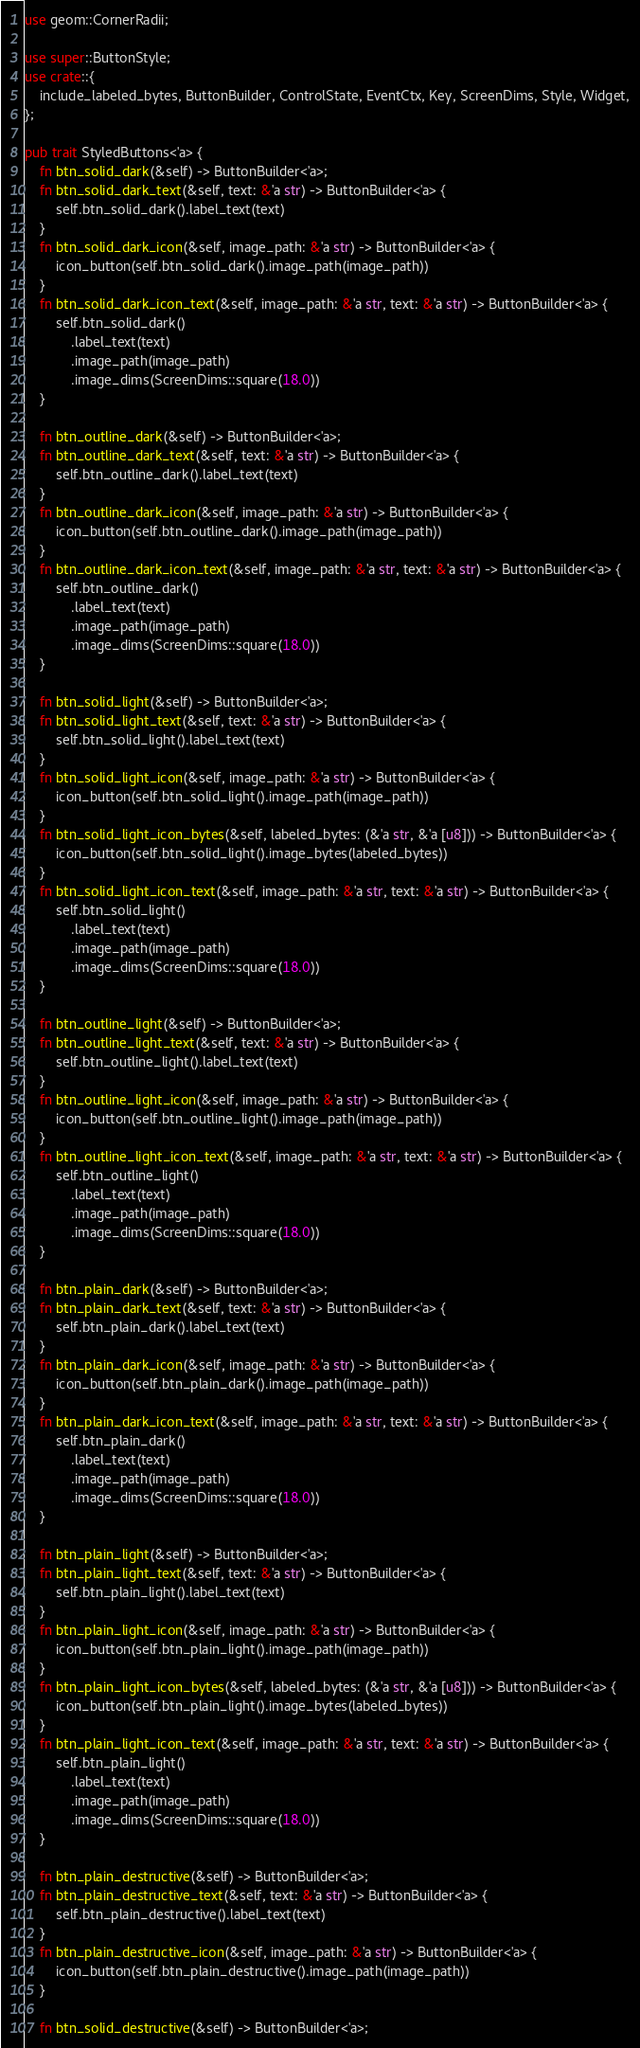<code> <loc_0><loc_0><loc_500><loc_500><_Rust_>use geom::CornerRadii;

use super::ButtonStyle;
use crate::{
    include_labeled_bytes, ButtonBuilder, ControlState, EventCtx, Key, ScreenDims, Style, Widget,
};

pub trait StyledButtons<'a> {
    fn btn_solid_dark(&self) -> ButtonBuilder<'a>;
    fn btn_solid_dark_text(&self, text: &'a str) -> ButtonBuilder<'a> {
        self.btn_solid_dark().label_text(text)
    }
    fn btn_solid_dark_icon(&self, image_path: &'a str) -> ButtonBuilder<'a> {
        icon_button(self.btn_solid_dark().image_path(image_path))
    }
    fn btn_solid_dark_icon_text(&self, image_path: &'a str, text: &'a str) -> ButtonBuilder<'a> {
        self.btn_solid_dark()
            .label_text(text)
            .image_path(image_path)
            .image_dims(ScreenDims::square(18.0))
    }

    fn btn_outline_dark(&self) -> ButtonBuilder<'a>;
    fn btn_outline_dark_text(&self, text: &'a str) -> ButtonBuilder<'a> {
        self.btn_outline_dark().label_text(text)
    }
    fn btn_outline_dark_icon(&self, image_path: &'a str) -> ButtonBuilder<'a> {
        icon_button(self.btn_outline_dark().image_path(image_path))
    }
    fn btn_outline_dark_icon_text(&self, image_path: &'a str, text: &'a str) -> ButtonBuilder<'a> {
        self.btn_outline_dark()
            .label_text(text)
            .image_path(image_path)
            .image_dims(ScreenDims::square(18.0))
    }

    fn btn_solid_light(&self) -> ButtonBuilder<'a>;
    fn btn_solid_light_text(&self, text: &'a str) -> ButtonBuilder<'a> {
        self.btn_solid_light().label_text(text)
    }
    fn btn_solid_light_icon(&self, image_path: &'a str) -> ButtonBuilder<'a> {
        icon_button(self.btn_solid_light().image_path(image_path))
    }
    fn btn_solid_light_icon_bytes(&self, labeled_bytes: (&'a str, &'a [u8])) -> ButtonBuilder<'a> {
        icon_button(self.btn_solid_light().image_bytes(labeled_bytes))
    }
    fn btn_solid_light_icon_text(&self, image_path: &'a str, text: &'a str) -> ButtonBuilder<'a> {
        self.btn_solid_light()
            .label_text(text)
            .image_path(image_path)
            .image_dims(ScreenDims::square(18.0))
    }

    fn btn_outline_light(&self) -> ButtonBuilder<'a>;
    fn btn_outline_light_text(&self, text: &'a str) -> ButtonBuilder<'a> {
        self.btn_outline_light().label_text(text)
    }
    fn btn_outline_light_icon(&self, image_path: &'a str) -> ButtonBuilder<'a> {
        icon_button(self.btn_outline_light().image_path(image_path))
    }
    fn btn_outline_light_icon_text(&self, image_path: &'a str, text: &'a str) -> ButtonBuilder<'a> {
        self.btn_outline_light()
            .label_text(text)
            .image_path(image_path)
            .image_dims(ScreenDims::square(18.0))
    }

    fn btn_plain_dark(&self) -> ButtonBuilder<'a>;
    fn btn_plain_dark_text(&self, text: &'a str) -> ButtonBuilder<'a> {
        self.btn_plain_dark().label_text(text)
    }
    fn btn_plain_dark_icon(&self, image_path: &'a str) -> ButtonBuilder<'a> {
        icon_button(self.btn_plain_dark().image_path(image_path))
    }
    fn btn_plain_dark_icon_text(&self, image_path: &'a str, text: &'a str) -> ButtonBuilder<'a> {
        self.btn_plain_dark()
            .label_text(text)
            .image_path(image_path)
            .image_dims(ScreenDims::square(18.0))
    }

    fn btn_plain_light(&self) -> ButtonBuilder<'a>;
    fn btn_plain_light_text(&self, text: &'a str) -> ButtonBuilder<'a> {
        self.btn_plain_light().label_text(text)
    }
    fn btn_plain_light_icon(&self, image_path: &'a str) -> ButtonBuilder<'a> {
        icon_button(self.btn_plain_light().image_path(image_path))
    }
    fn btn_plain_light_icon_bytes(&self, labeled_bytes: (&'a str, &'a [u8])) -> ButtonBuilder<'a> {
        icon_button(self.btn_plain_light().image_bytes(labeled_bytes))
    }
    fn btn_plain_light_icon_text(&self, image_path: &'a str, text: &'a str) -> ButtonBuilder<'a> {
        self.btn_plain_light()
            .label_text(text)
            .image_path(image_path)
            .image_dims(ScreenDims::square(18.0))
    }

    fn btn_plain_destructive(&self) -> ButtonBuilder<'a>;
    fn btn_plain_destructive_text(&self, text: &'a str) -> ButtonBuilder<'a> {
        self.btn_plain_destructive().label_text(text)
    }
    fn btn_plain_destructive_icon(&self, image_path: &'a str) -> ButtonBuilder<'a> {
        icon_button(self.btn_plain_destructive().image_path(image_path))
    }

    fn btn_solid_destructive(&self) -> ButtonBuilder<'a>;</code> 